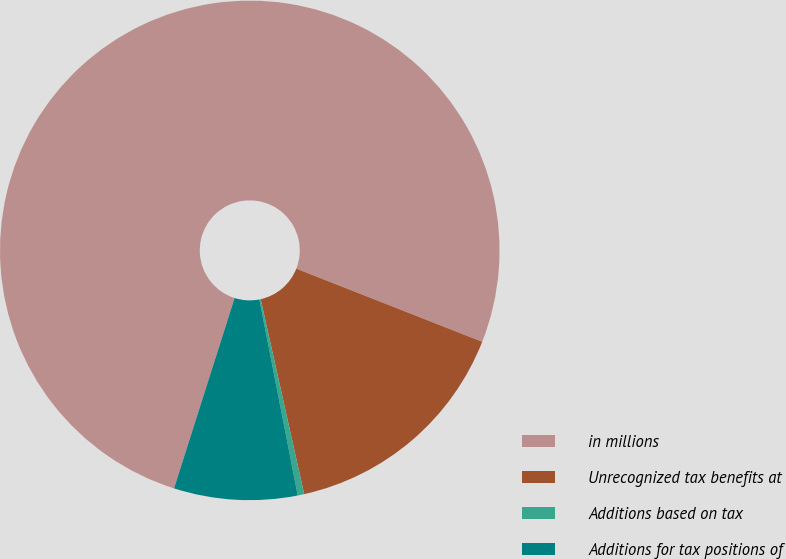Convert chart. <chart><loc_0><loc_0><loc_500><loc_500><pie_chart><fcel>in millions<fcel>Unrecognized tax benefits at<fcel>Additions based on tax<fcel>Additions for tax positions of<nl><fcel>76.06%<fcel>15.54%<fcel>0.42%<fcel>7.98%<nl></chart> 